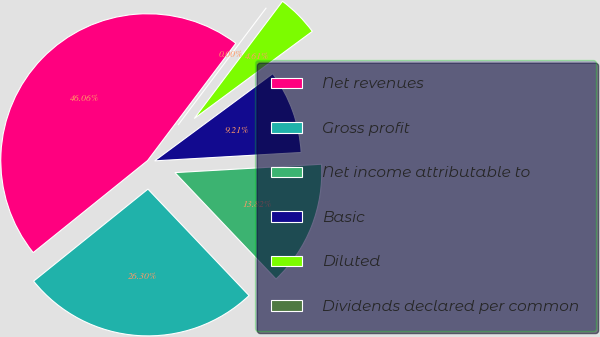Convert chart. <chart><loc_0><loc_0><loc_500><loc_500><pie_chart><fcel>Net revenues<fcel>Gross profit<fcel>Net income attributable to<fcel>Basic<fcel>Diluted<fcel>Dividends declared per common<nl><fcel>46.06%<fcel>26.3%<fcel>13.82%<fcel>9.21%<fcel>4.61%<fcel>0.0%<nl></chart> 